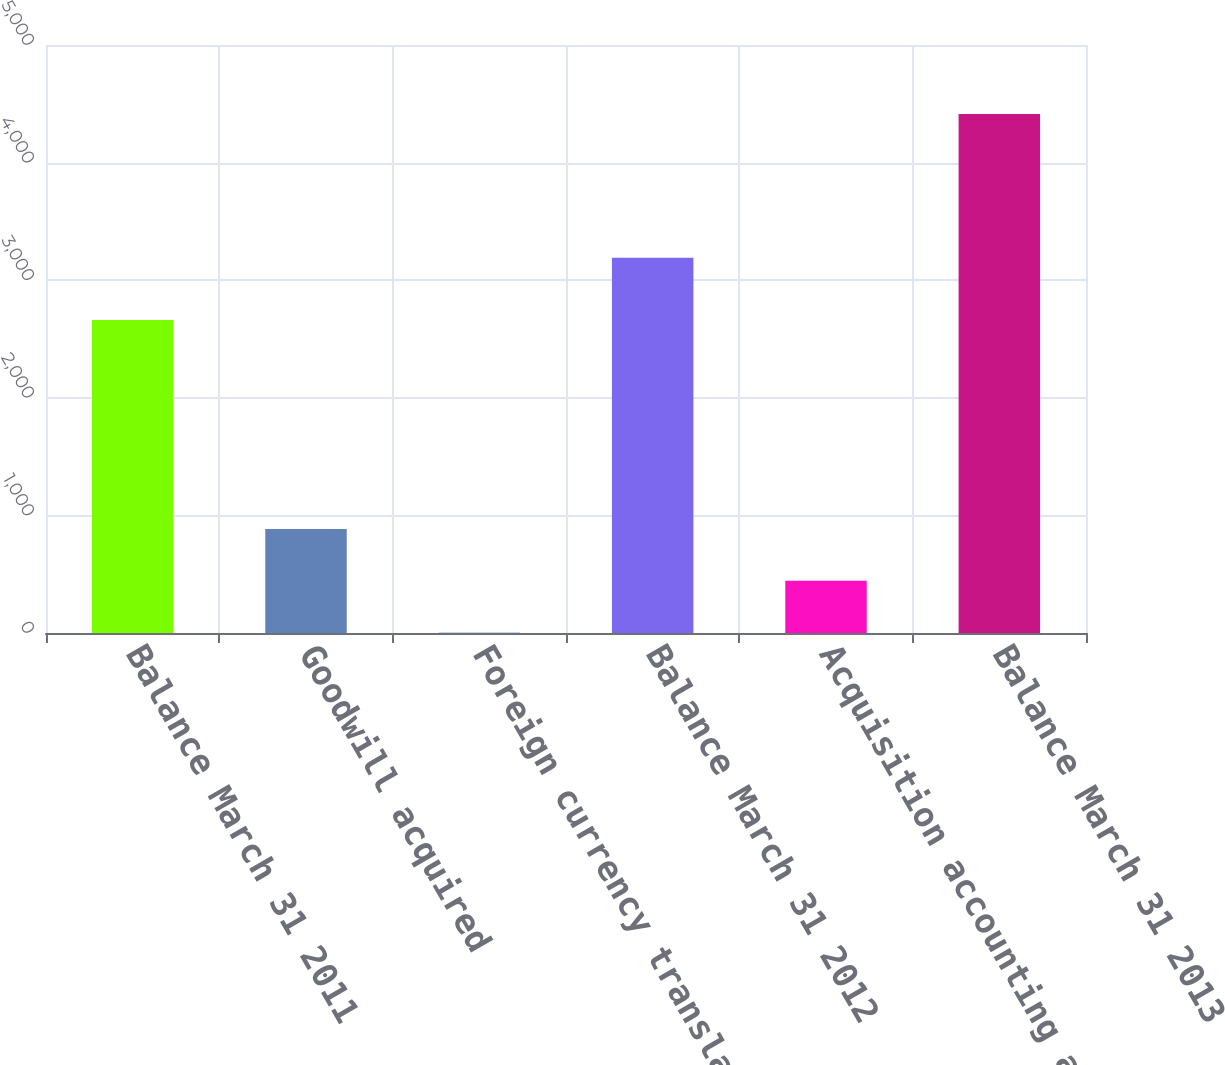<chart> <loc_0><loc_0><loc_500><loc_500><bar_chart><fcel>Balance March 31 2011<fcel>Goodwill acquired<fcel>Foreign currency translation<fcel>Balance March 31 2012<fcel>Acquisition accounting and<fcel>Balance March 31 2013<nl><fcel>2662<fcel>885<fcel>3<fcel>3190<fcel>444<fcel>4413<nl></chart> 